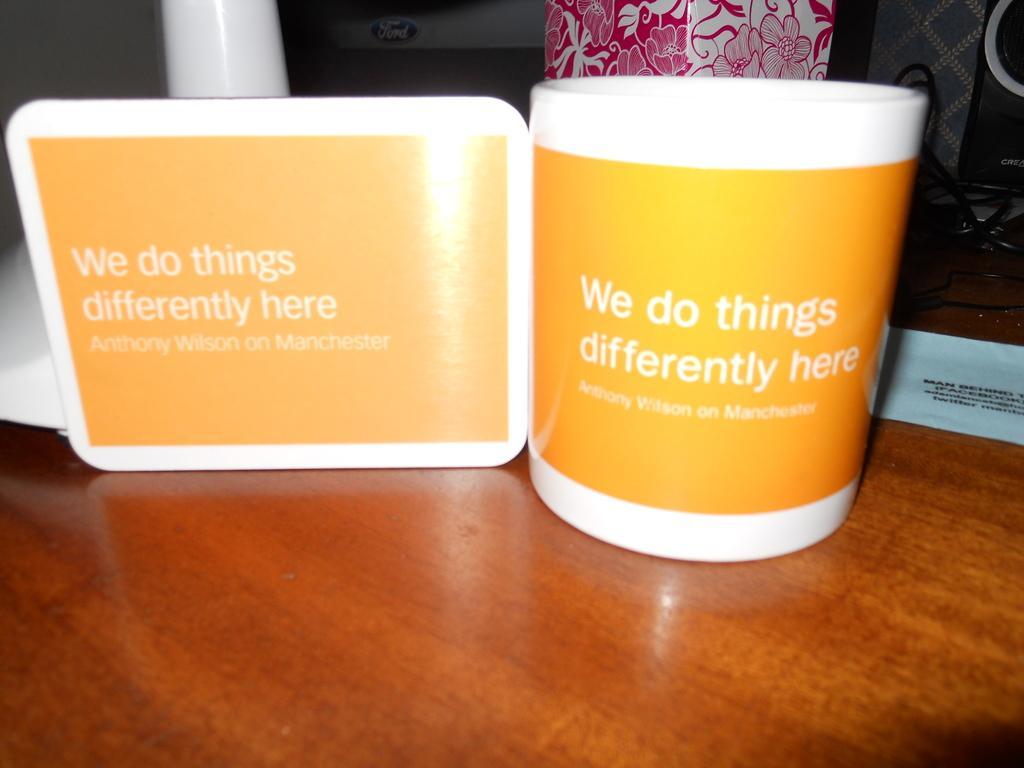In one or two sentences, can you explain what this image depicts? In the picture there is a cup on which it is written as " we do things differently here" there is also a white color board same thing written on them both of them are placed on a wooden table in the background there is a speaker and a ford symbol. 